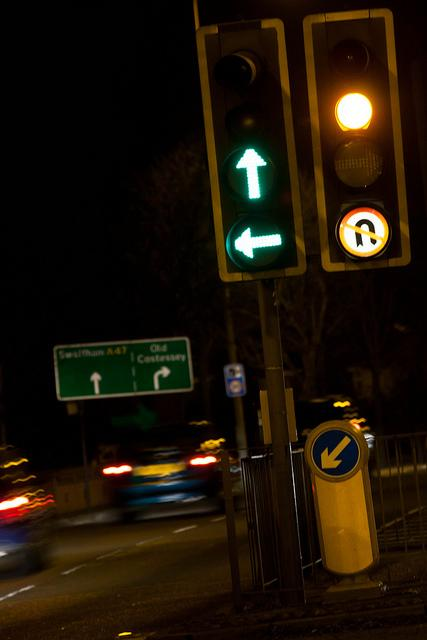What type of signs are these?

Choices:
A) direction signs
B) traffic signs
C) helpful signs
D) schoolzone signs traffic signs 